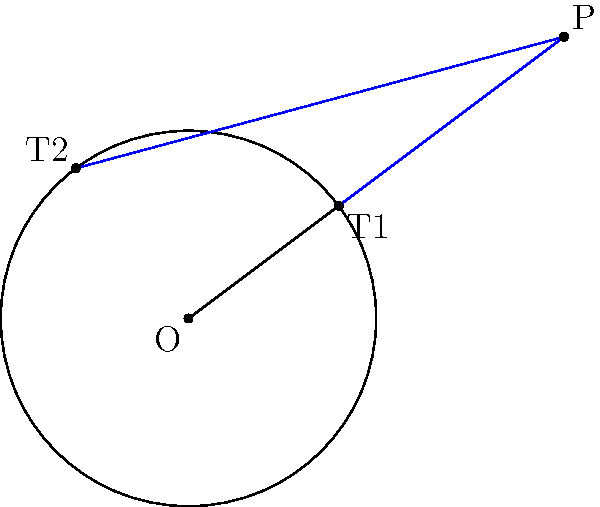In the diagram, P is an external point to a circle with center O and radius r. Two tangent lines are drawn from P to the circle, touching at points T1 and T2. If the distance between P and O is x, prove that the angle between the two tangent lines is given by $$\theta = 2\arccos\left(\frac{r}{x}\right)$$ How would this formula be useful in optimizing the placement of sensors around a circular facility for maximum coverage? Let's approach this step-by-step:

1) In right triangle POT1:
   $$\cos(\frac{\theta}{2}) = \frac{r}{x}$$

2) Rearranging this equation:
   $$\frac{\theta}{2} = \arccos\left(\frac{r}{x}\right)$$

3) Multiplying both sides by 2:
   $$\theta = 2\arccos\left(\frac{r}{x}\right)$$

This formula is proved.

Practical application:
1) The formula allows quick calculation of the angle between tangent lines for any external point.
2) For sensor placement, this helps determine:
   a) The optimal distance (x) for sensors to achieve a desired coverage angle (θ).
   b) The coverage angle for sensors placed at a specific distance.
3) By optimizing x, we can minimize the number of sensors needed while maximizing coverage.
4) This leads to cost-effective security solutions and efficient resource allocation.
Answer: $\theta = 2\arccos\left(\frac{r}{x}\right)$ 